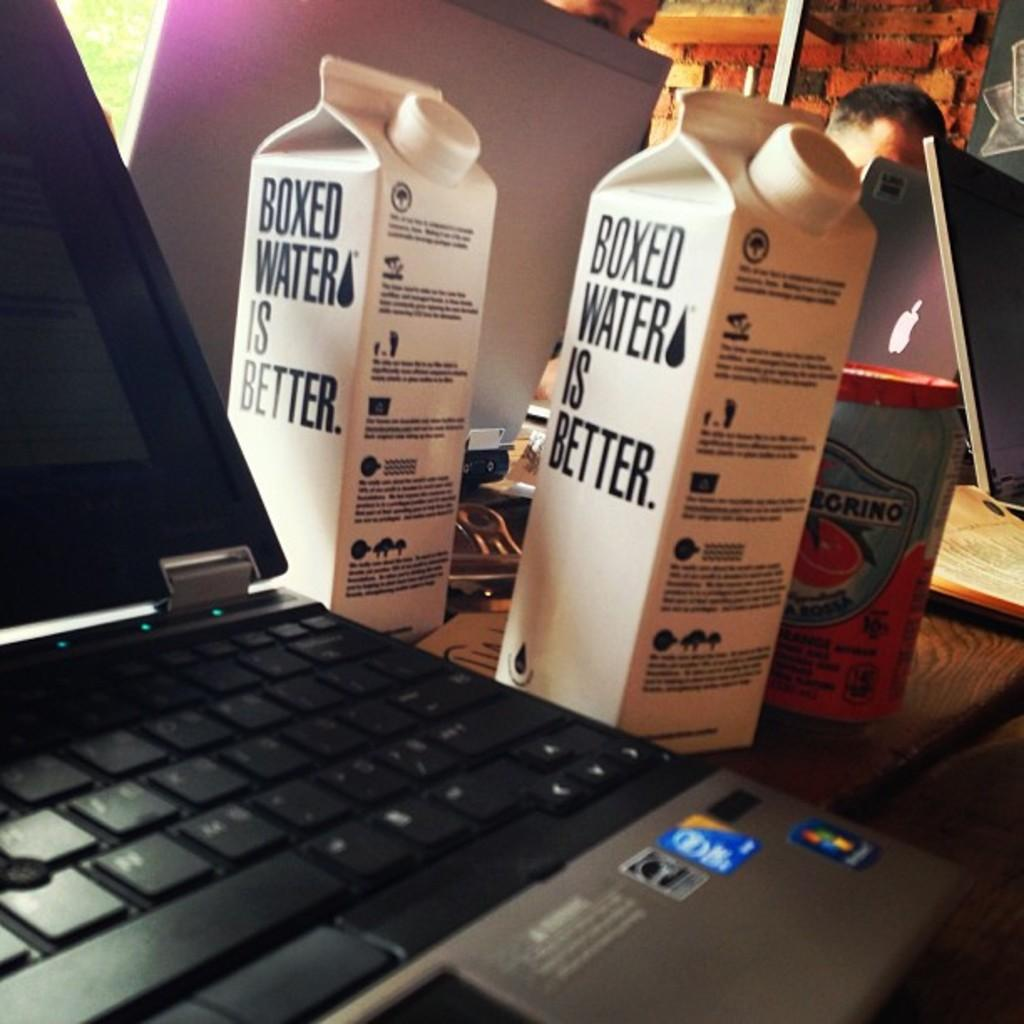<image>
Offer a succinct explanation of the picture presented. A laptop sits next to two boxes of water which each state that Boxed Water is better. 